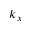<formula> <loc_0><loc_0><loc_500><loc_500>k _ { x }</formula> 